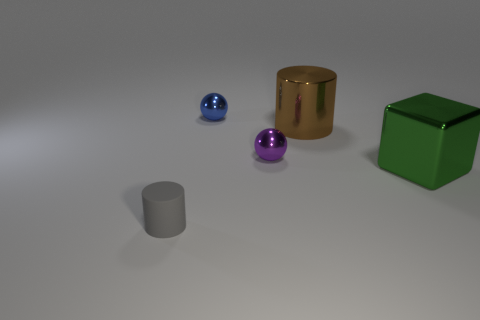The green thing has what size?
Provide a succinct answer. Large. Is there a small metallic thing of the same color as the small cylinder?
Offer a very short reply. No. There is a cylinder that is the same size as the green cube; what color is it?
Offer a terse response. Brown. What material is the tiny ball that is behind the cylinder right of the cylinder that is to the left of the metallic cylinder?
Provide a succinct answer. Metal. Is the color of the tiny rubber thing the same as the tiny metallic thing behind the big brown thing?
Give a very brief answer. No. How many things are either things that are in front of the large green metal block or metal objects behind the green cube?
Your answer should be compact. 4. There is a tiny thing in front of the metal object in front of the purple metallic object; what is its shape?
Ensure brevity in your answer.  Cylinder. Are there any blue things that have the same material as the green thing?
Your answer should be very brief. Yes. There is another shiny thing that is the same shape as the purple thing; what is its color?
Provide a succinct answer. Blue. Is the number of tiny blue balls that are in front of the blue sphere less than the number of metal cylinders left of the tiny gray cylinder?
Offer a terse response. No. 